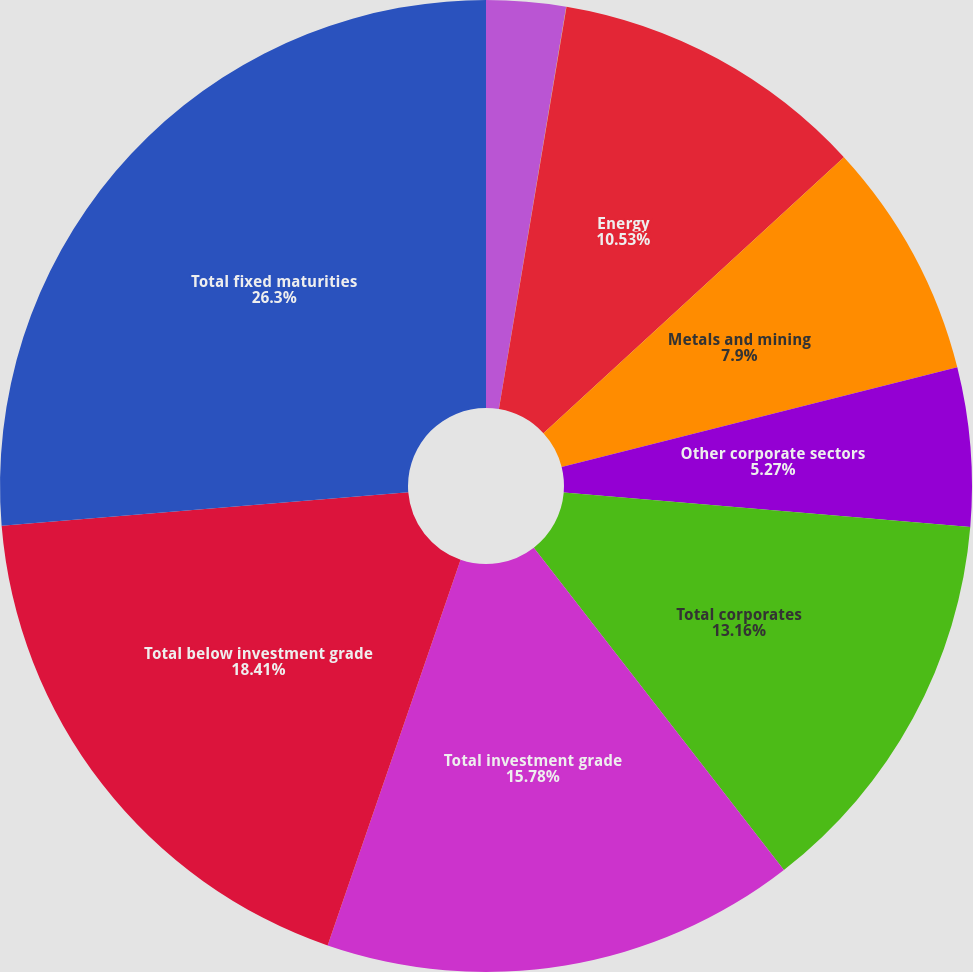Convert chart. <chart><loc_0><loc_0><loc_500><loc_500><pie_chart><fcel>US Government direct<fcel>States municipalities and<fcel>Energy<fcel>Metals and mining<fcel>Other corporate sectors<fcel>Total corporates<fcel>Total investment grade<fcel>Total below investment grade<fcel>Total fixed maturities<nl><fcel>2.64%<fcel>0.01%<fcel>10.53%<fcel>7.9%<fcel>5.27%<fcel>13.16%<fcel>15.79%<fcel>18.42%<fcel>26.31%<nl></chart> 